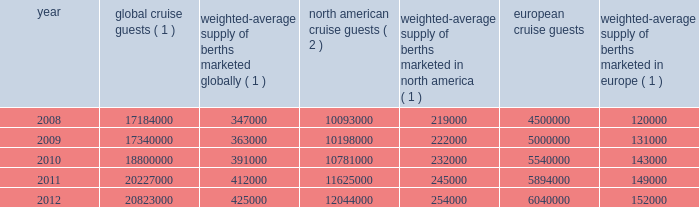Result of the effects of the costa concordia incident and the continued instability in the european eco- nomic landscape .
However , we continue to believe in the long term growth potential of this market .
We estimate that europe was served by 102 ships with approximately 108000 berths at the beginning of 2008 and by 117 ships with approximately 156000 berths at the end of 2012 .
There are approximately 9 ships with an estimated 25000 berths that are expected to be placed in service in the european cruise market between 2013 and 2017 .
The table details the growth in the global , north american and european cruise markets in terms of cruise guests and estimated weighted-average berths over the past five years : global cruise guests ( 1 ) weighted-average supply of berths marketed globally ( 1 ) north american cruise guests ( 2 ) weighted-average supply of berths marketed in north america ( 1 ) european cruise guests weighted-average supply of berths marketed in europe ( 1 ) .
( 1 ) source : our estimates of the number of global cruise guests , and the weighted-average supply of berths marketed globally , in north america and europe are based on a combination of data that we obtain from various publicly available cruise industry trade information sources including seatrade insider and cruise line international association ( 201cclia 201d ) .
In addition , our estimates incorporate our own statistical analysis utilizing the same publicly available cruise industry data as a base .
( 2 ) source : cruise line international association based on cruise guests carried for at least two consecutive nights for years 2008 through 2011 .
Year 2012 amounts represent our estimates ( see number 1 above ) .
( 3 ) source : clia europe , formerly european cruise council , for years 2008 through 2011 .
Year 2012 amounts represent our estimates ( see number 1 above ) .
Other markets in addition to expected industry growth in north america and europe as discussed above , we expect the asia/pacific region to demonstrate an even higher growth rate in the near term , although it will continue to represent a relatively small sector compared to north america and europe .
Competition we compete with a number of cruise lines .
Our princi- pal competitors are carnival corporation & plc , which owns , among others , aida cruises , carnival cruise lines , costa cruises , cunard line , holland america line , iberocruceros , p&o cruises and princess cruises ; disney cruise line ; msc cruises ; norwegian cruise line and oceania cruises .
Cruise lines compete with other vacation alternatives such as land-based resort hotels and sightseeing destinations for consumers 2019 leisure time .
Demand for such activities is influenced by political and general economic conditions .
Com- panies within the vacation market are dependent on consumer discretionary spending .
Operating strategies our principal operating strategies are to : 2022 protect the health , safety and security of our guests and employees and protect the environment in which our vessels and organization operate , 2022 strengthen and support our human capital in order to better serve our global guest base and grow our business , 2022 further strengthen our consumer engagement in order to enhance our revenues , 2022 increase the awareness and market penetration of our brands globally , 2022 focus on cost efficiency , manage our operating expenditures and ensure adequate cash and liquid- ity , with the overall goal of maximizing our return on invested capital and long-term shareholder value , 2022 strategically invest in our fleet through the revit ad alization of existing ships and the transfer of key innovations across each brand , while prudently expanding our fleet with the new state-of-the-art cruise ships recently delivered and on order , 2022 capitalize on the portability and flexibility of our ships by deploying them into those markets and itineraries that provide opportunities to optimize returns , while continuing our focus on existing key markets , 2022 further enhance our technological capabilities to service customer preferences and expectations in an innovative manner , while supporting our strategic focus on profitability , and part i 0494.indd 13 3/27/13 12:52 pm .
What was the approximate increase of berths per ships for 2012 compared to 2008? 
Computations: ((156000 / 117) - (108000 / 102))
Answer: 274.5098. 